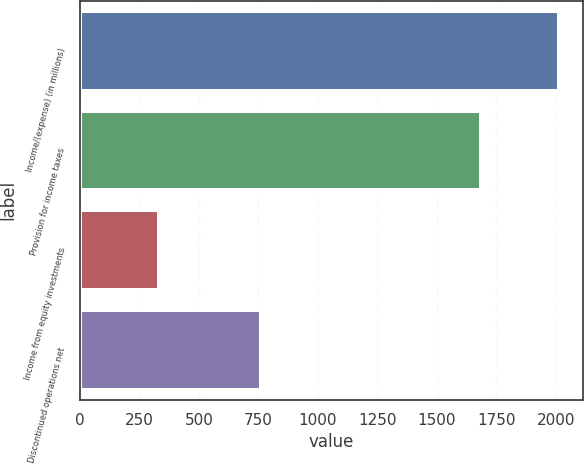Convert chart to OTSL. <chart><loc_0><loc_0><loc_500><loc_500><bar_chart><fcel>Income/(expense) (in millions)<fcel>Provision for income taxes<fcel>Income from equity investments<fcel>Discontinued operations net<nl><fcel>2014<fcel>1685<fcel>331<fcel>760<nl></chart> 